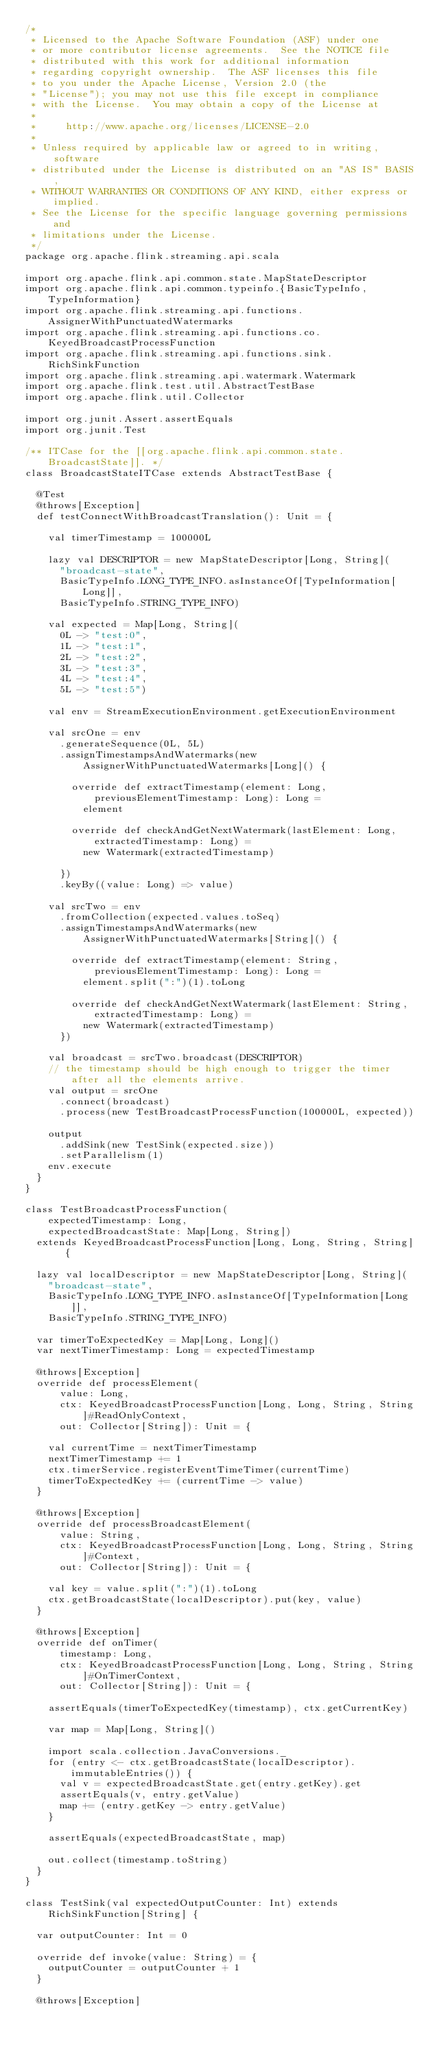<code> <loc_0><loc_0><loc_500><loc_500><_Scala_>/*
 * Licensed to the Apache Software Foundation (ASF) under one
 * or more contributor license agreements.  See the NOTICE file
 * distributed with this work for additional information
 * regarding copyright ownership.  The ASF licenses this file
 * to you under the Apache License, Version 2.0 (the
 * "License"); you may not use this file except in compliance
 * with the License.  You may obtain a copy of the License at
 *
 *     http://www.apache.org/licenses/LICENSE-2.0
 *
 * Unless required by applicable law or agreed to in writing, software
 * distributed under the License is distributed on an "AS IS" BASIS,
 * WITHOUT WARRANTIES OR CONDITIONS OF ANY KIND, either express or implied.
 * See the License for the specific language governing permissions and
 * limitations under the License.
 */
package org.apache.flink.streaming.api.scala

import org.apache.flink.api.common.state.MapStateDescriptor
import org.apache.flink.api.common.typeinfo.{BasicTypeInfo, TypeInformation}
import org.apache.flink.streaming.api.functions.AssignerWithPunctuatedWatermarks
import org.apache.flink.streaming.api.functions.co.KeyedBroadcastProcessFunction
import org.apache.flink.streaming.api.functions.sink.RichSinkFunction
import org.apache.flink.streaming.api.watermark.Watermark
import org.apache.flink.test.util.AbstractTestBase
import org.apache.flink.util.Collector

import org.junit.Assert.assertEquals
import org.junit.Test

/** ITCase for the [[org.apache.flink.api.common.state.BroadcastState]]. */
class BroadcastStateITCase extends AbstractTestBase {

  @Test
  @throws[Exception]
  def testConnectWithBroadcastTranslation(): Unit = {

    val timerTimestamp = 100000L

    lazy val DESCRIPTOR = new MapStateDescriptor[Long, String](
      "broadcast-state",
      BasicTypeInfo.LONG_TYPE_INFO.asInstanceOf[TypeInformation[Long]],
      BasicTypeInfo.STRING_TYPE_INFO)

    val expected = Map[Long, String](
      0L -> "test:0",
      1L -> "test:1",
      2L -> "test:2",
      3L -> "test:3",
      4L -> "test:4",
      5L -> "test:5")

    val env = StreamExecutionEnvironment.getExecutionEnvironment

    val srcOne = env
      .generateSequence(0L, 5L)
      .assignTimestampsAndWatermarks(new AssignerWithPunctuatedWatermarks[Long]() {

        override def extractTimestamp(element: Long, previousElementTimestamp: Long): Long =
          element

        override def checkAndGetNextWatermark(lastElement: Long, extractedTimestamp: Long) =
          new Watermark(extractedTimestamp)

      })
      .keyBy((value: Long) => value)

    val srcTwo = env
      .fromCollection(expected.values.toSeq)
      .assignTimestampsAndWatermarks(new AssignerWithPunctuatedWatermarks[String]() {

        override def extractTimestamp(element: String, previousElementTimestamp: Long): Long =
          element.split(":")(1).toLong

        override def checkAndGetNextWatermark(lastElement: String, extractedTimestamp: Long) =
          new Watermark(extractedTimestamp)
      })

    val broadcast = srcTwo.broadcast(DESCRIPTOR)
    // the timestamp should be high enough to trigger the timer after all the elements arrive.
    val output = srcOne
      .connect(broadcast)
      .process(new TestBroadcastProcessFunction(100000L, expected))

    output
      .addSink(new TestSink(expected.size))
      .setParallelism(1)
    env.execute
  }
}

class TestBroadcastProcessFunction(
    expectedTimestamp: Long,
    expectedBroadcastState: Map[Long, String])
  extends KeyedBroadcastProcessFunction[Long, Long, String, String] {

  lazy val localDescriptor = new MapStateDescriptor[Long, String](
    "broadcast-state",
    BasicTypeInfo.LONG_TYPE_INFO.asInstanceOf[TypeInformation[Long]],
    BasicTypeInfo.STRING_TYPE_INFO)

  var timerToExpectedKey = Map[Long, Long]()
  var nextTimerTimestamp: Long = expectedTimestamp

  @throws[Exception]
  override def processElement(
      value: Long,
      ctx: KeyedBroadcastProcessFunction[Long, Long, String, String]#ReadOnlyContext,
      out: Collector[String]): Unit = {

    val currentTime = nextTimerTimestamp
    nextTimerTimestamp += 1
    ctx.timerService.registerEventTimeTimer(currentTime)
    timerToExpectedKey += (currentTime -> value)
  }

  @throws[Exception]
  override def processBroadcastElement(
      value: String,
      ctx: KeyedBroadcastProcessFunction[Long, Long, String, String]#Context,
      out: Collector[String]): Unit = {

    val key = value.split(":")(1).toLong
    ctx.getBroadcastState(localDescriptor).put(key, value)
  }

  @throws[Exception]
  override def onTimer(
      timestamp: Long,
      ctx: KeyedBroadcastProcessFunction[Long, Long, String, String]#OnTimerContext,
      out: Collector[String]): Unit = {

    assertEquals(timerToExpectedKey(timestamp), ctx.getCurrentKey)

    var map = Map[Long, String]()

    import scala.collection.JavaConversions._
    for (entry <- ctx.getBroadcastState(localDescriptor).immutableEntries()) {
      val v = expectedBroadcastState.get(entry.getKey).get
      assertEquals(v, entry.getValue)
      map += (entry.getKey -> entry.getValue)
    }

    assertEquals(expectedBroadcastState, map)

    out.collect(timestamp.toString)
  }
}

class TestSink(val expectedOutputCounter: Int) extends RichSinkFunction[String] {

  var outputCounter: Int = 0

  override def invoke(value: String) = {
    outputCounter = outputCounter + 1
  }

  @throws[Exception]</code> 